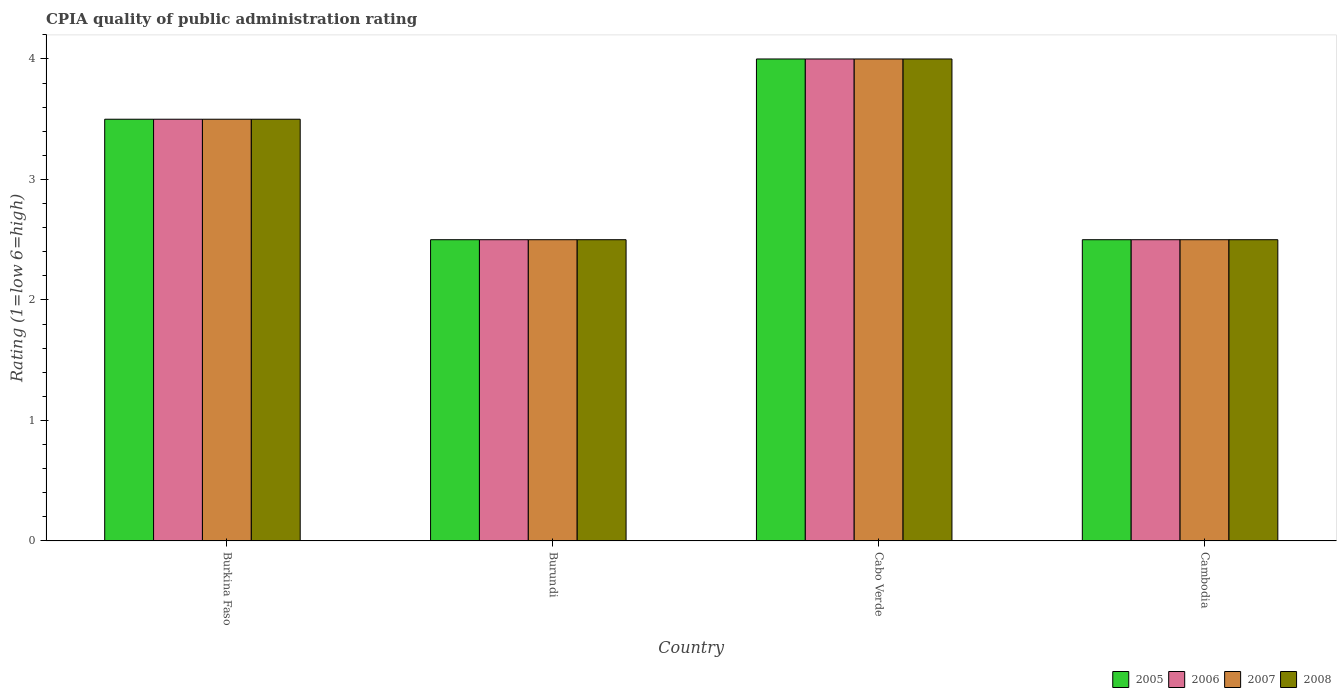How many different coloured bars are there?
Keep it short and to the point. 4. How many groups of bars are there?
Offer a very short reply. 4. What is the label of the 4th group of bars from the left?
Keep it short and to the point. Cambodia. Across all countries, what is the maximum CPIA rating in 2007?
Your answer should be very brief. 4. Across all countries, what is the minimum CPIA rating in 2006?
Offer a terse response. 2.5. In which country was the CPIA rating in 2007 maximum?
Provide a succinct answer. Cabo Verde. In which country was the CPIA rating in 2008 minimum?
Keep it short and to the point. Burundi. What is the difference between the CPIA rating in 2005 in Burundi and that in Cambodia?
Offer a very short reply. 0. What is the average CPIA rating in 2007 per country?
Provide a succinct answer. 3.12. In how many countries, is the CPIA rating in 2008 greater than 3.6?
Give a very brief answer. 1. Is the difference between the CPIA rating in 2005 in Burkina Faso and Burundi greater than the difference between the CPIA rating in 2006 in Burkina Faso and Burundi?
Your answer should be compact. No. What is the difference between the highest and the second highest CPIA rating in 2007?
Keep it short and to the point. -1. What is the difference between the highest and the lowest CPIA rating in 2006?
Provide a succinct answer. 1.5. In how many countries, is the CPIA rating in 2005 greater than the average CPIA rating in 2005 taken over all countries?
Make the answer very short. 2. Is the sum of the CPIA rating in 2005 in Cabo Verde and Cambodia greater than the maximum CPIA rating in 2006 across all countries?
Provide a short and direct response. Yes. Is it the case that in every country, the sum of the CPIA rating in 2007 and CPIA rating in 2005 is greater than the sum of CPIA rating in 2008 and CPIA rating in 2006?
Ensure brevity in your answer.  No. How many countries are there in the graph?
Give a very brief answer. 4. What is the difference between two consecutive major ticks on the Y-axis?
Your answer should be very brief. 1. Does the graph contain any zero values?
Offer a very short reply. No. Does the graph contain grids?
Your answer should be compact. No. How many legend labels are there?
Keep it short and to the point. 4. What is the title of the graph?
Ensure brevity in your answer.  CPIA quality of public administration rating. What is the label or title of the X-axis?
Ensure brevity in your answer.  Country. What is the Rating (1=low 6=high) of 2005 in Burkina Faso?
Your response must be concise. 3.5. What is the Rating (1=low 6=high) in 2008 in Burkina Faso?
Keep it short and to the point. 3.5. What is the Rating (1=low 6=high) of 2005 in Burundi?
Offer a terse response. 2.5. What is the Rating (1=low 6=high) of 2007 in Burundi?
Your response must be concise. 2.5. What is the Rating (1=low 6=high) in 2006 in Cabo Verde?
Your response must be concise. 4. What is the Rating (1=low 6=high) of 2007 in Cabo Verde?
Give a very brief answer. 4. What is the Rating (1=low 6=high) in 2006 in Cambodia?
Give a very brief answer. 2.5. What is the Rating (1=low 6=high) of 2007 in Cambodia?
Your answer should be very brief. 2.5. What is the Rating (1=low 6=high) of 2008 in Cambodia?
Your response must be concise. 2.5. Across all countries, what is the maximum Rating (1=low 6=high) in 2005?
Offer a very short reply. 4. Across all countries, what is the maximum Rating (1=low 6=high) in 2006?
Make the answer very short. 4. Across all countries, what is the maximum Rating (1=low 6=high) in 2008?
Make the answer very short. 4. What is the total Rating (1=low 6=high) of 2007 in the graph?
Offer a very short reply. 12.5. What is the total Rating (1=low 6=high) of 2008 in the graph?
Provide a short and direct response. 12.5. What is the difference between the Rating (1=low 6=high) of 2005 in Burkina Faso and that in Burundi?
Your answer should be very brief. 1. What is the difference between the Rating (1=low 6=high) in 2006 in Burkina Faso and that in Burundi?
Ensure brevity in your answer.  1. What is the difference between the Rating (1=low 6=high) of 2007 in Burkina Faso and that in Burundi?
Keep it short and to the point. 1. What is the difference between the Rating (1=low 6=high) of 2008 in Burkina Faso and that in Burundi?
Give a very brief answer. 1. What is the difference between the Rating (1=low 6=high) of 2005 in Burkina Faso and that in Cabo Verde?
Ensure brevity in your answer.  -0.5. What is the difference between the Rating (1=low 6=high) of 2006 in Burkina Faso and that in Cabo Verde?
Offer a very short reply. -0.5. What is the difference between the Rating (1=low 6=high) of 2007 in Burkina Faso and that in Cabo Verde?
Provide a short and direct response. -0.5. What is the difference between the Rating (1=low 6=high) of 2008 in Burkina Faso and that in Cabo Verde?
Offer a very short reply. -0.5. What is the difference between the Rating (1=low 6=high) of 2008 in Burkina Faso and that in Cambodia?
Offer a very short reply. 1. What is the difference between the Rating (1=low 6=high) in 2007 in Burundi and that in Cabo Verde?
Your response must be concise. -1.5. What is the difference between the Rating (1=low 6=high) of 2005 in Burundi and that in Cambodia?
Make the answer very short. 0. What is the difference between the Rating (1=low 6=high) in 2006 in Burundi and that in Cambodia?
Keep it short and to the point. 0. What is the difference between the Rating (1=low 6=high) in 2007 in Burundi and that in Cambodia?
Make the answer very short. 0. What is the difference between the Rating (1=low 6=high) of 2008 in Burundi and that in Cambodia?
Make the answer very short. 0. What is the difference between the Rating (1=low 6=high) in 2005 in Cabo Verde and that in Cambodia?
Offer a very short reply. 1.5. What is the difference between the Rating (1=low 6=high) in 2006 in Cabo Verde and that in Cambodia?
Offer a terse response. 1.5. What is the difference between the Rating (1=low 6=high) in 2005 in Burkina Faso and the Rating (1=low 6=high) in 2006 in Burundi?
Offer a terse response. 1. What is the difference between the Rating (1=low 6=high) of 2005 in Burkina Faso and the Rating (1=low 6=high) of 2008 in Burundi?
Your response must be concise. 1. What is the difference between the Rating (1=low 6=high) of 2006 in Burkina Faso and the Rating (1=low 6=high) of 2007 in Burundi?
Keep it short and to the point. 1. What is the difference between the Rating (1=low 6=high) in 2006 in Burkina Faso and the Rating (1=low 6=high) in 2008 in Burundi?
Keep it short and to the point. 1. What is the difference between the Rating (1=low 6=high) in 2007 in Burkina Faso and the Rating (1=low 6=high) in 2008 in Burundi?
Your answer should be very brief. 1. What is the difference between the Rating (1=low 6=high) in 2005 in Burkina Faso and the Rating (1=low 6=high) in 2007 in Cabo Verde?
Offer a terse response. -0.5. What is the difference between the Rating (1=low 6=high) of 2005 in Burkina Faso and the Rating (1=low 6=high) of 2008 in Cabo Verde?
Your response must be concise. -0.5. What is the difference between the Rating (1=low 6=high) in 2005 in Burundi and the Rating (1=low 6=high) in 2007 in Cabo Verde?
Give a very brief answer. -1.5. What is the difference between the Rating (1=low 6=high) of 2005 in Burundi and the Rating (1=low 6=high) of 2008 in Cabo Verde?
Make the answer very short. -1.5. What is the difference between the Rating (1=low 6=high) of 2006 in Burundi and the Rating (1=low 6=high) of 2008 in Cabo Verde?
Give a very brief answer. -1.5. What is the difference between the Rating (1=low 6=high) in 2005 in Burundi and the Rating (1=low 6=high) in 2006 in Cambodia?
Provide a short and direct response. 0. What is the difference between the Rating (1=low 6=high) in 2007 in Burundi and the Rating (1=low 6=high) in 2008 in Cambodia?
Your answer should be very brief. 0. What is the average Rating (1=low 6=high) of 2005 per country?
Provide a short and direct response. 3.12. What is the average Rating (1=low 6=high) in 2006 per country?
Give a very brief answer. 3.12. What is the average Rating (1=low 6=high) in 2007 per country?
Your response must be concise. 3.12. What is the average Rating (1=low 6=high) of 2008 per country?
Give a very brief answer. 3.12. What is the difference between the Rating (1=low 6=high) of 2005 and Rating (1=low 6=high) of 2006 in Burkina Faso?
Your response must be concise. 0. What is the difference between the Rating (1=low 6=high) in 2006 and Rating (1=low 6=high) in 2008 in Burkina Faso?
Give a very brief answer. 0. What is the difference between the Rating (1=low 6=high) of 2006 and Rating (1=low 6=high) of 2007 in Burundi?
Your answer should be very brief. 0. What is the difference between the Rating (1=low 6=high) of 2005 and Rating (1=low 6=high) of 2006 in Cabo Verde?
Your answer should be very brief. 0. What is the difference between the Rating (1=low 6=high) in 2005 and Rating (1=low 6=high) in 2008 in Cabo Verde?
Keep it short and to the point. 0. What is the difference between the Rating (1=low 6=high) of 2005 and Rating (1=low 6=high) of 2006 in Cambodia?
Provide a short and direct response. 0. What is the difference between the Rating (1=low 6=high) in 2005 and Rating (1=low 6=high) in 2007 in Cambodia?
Your response must be concise. 0. What is the difference between the Rating (1=low 6=high) in 2005 and Rating (1=low 6=high) in 2008 in Cambodia?
Your answer should be compact. 0. What is the difference between the Rating (1=low 6=high) of 2007 and Rating (1=low 6=high) of 2008 in Cambodia?
Offer a terse response. 0. What is the ratio of the Rating (1=low 6=high) of 2006 in Burkina Faso to that in Burundi?
Offer a terse response. 1.4. What is the ratio of the Rating (1=low 6=high) of 2007 in Burkina Faso to that in Burundi?
Offer a very short reply. 1.4. What is the ratio of the Rating (1=low 6=high) in 2008 in Burkina Faso to that in Burundi?
Offer a terse response. 1.4. What is the ratio of the Rating (1=low 6=high) of 2005 in Burkina Faso to that in Cabo Verde?
Make the answer very short. 0.88. What is the ratio of the Rating (1=low 6=high) of 2006 in Burkina Faso to that in Cabo Verde?
Your response must be concise. 0.88. What is the ratio of the Rating (1=low 6=high) of 2008 in Burkina Faso to that in Cabo Verde?
Ensure brevity in your answer.  0.88. What is the ratio of the Rating (1=low 6=high) of 2005 in Burkina Faso to that in Cambodia?
Offer a terse response. 1.4. What is the ratio of the Rating (1=low 6=high) of 2006 in Burkina Faso to that in Cambodia?
Ensure brevity in your answer.  1.4. What is the ratio of the Rating (1=low 6=high) in 2007 in Burkina Faso to that in Cambodia?
Keep it short and to the point. 1.4. What is the ratio of the Rating (1=low 6=high) in 2008 in Burkina Faso to that in Cambodia?
Give a very brief answer. 1.4. What is the ratio of the Rating (1=low 6=high) of 2005 in Burundi to that in Cambodia?
Your answer should be very brief. 1. What is the ratio of the Rating (1=low 6=high) of 2006 in Burundi to that in Cambodia?
Your response must be concise. 1. What is the ratio of the Rating (1=low 6=high) of 2007 in Burundi to that in Cambodia?
Keep it short and to the point. 1. What is the ratio of the Rating (1=low 6=high) of 2005 in Cabo Verde to that in Cambodia?
Provide a succinct answer. 1.6. What is the ratio of the Rating (1=low 6=high) of 2006 in Cabo Verde to that in Cambodia?
Your response must be concise. 1.6. What is the ratio of the Rating (1=low 6=high) in 2007 in Cabo Verde to that in Cambodia?
Provide a short and direct response. 1.6. What is the ratio of the Rating (1=low 6=high) in 2008 in Cabo Verde to that in Cambodia?
Provide a succinct answer. 1.6. What is the difference between the highest and the second highest Rating (1=low 6=high) of 2005?
Offer a terse response. 0.5. What is the difference between the highest and the second highest Rating (1=low 6=high) in 2008?
Offer a terse response. 0.5. What is the difference between the highest and the lowest Rating (1=low 6=high) of 2007?
Ensure brevity in your answer.  1.5. What is the difference between the highest and the lowest Rating (1=low 6=high) in 2008?
Offer a very short reply. 1.5. 